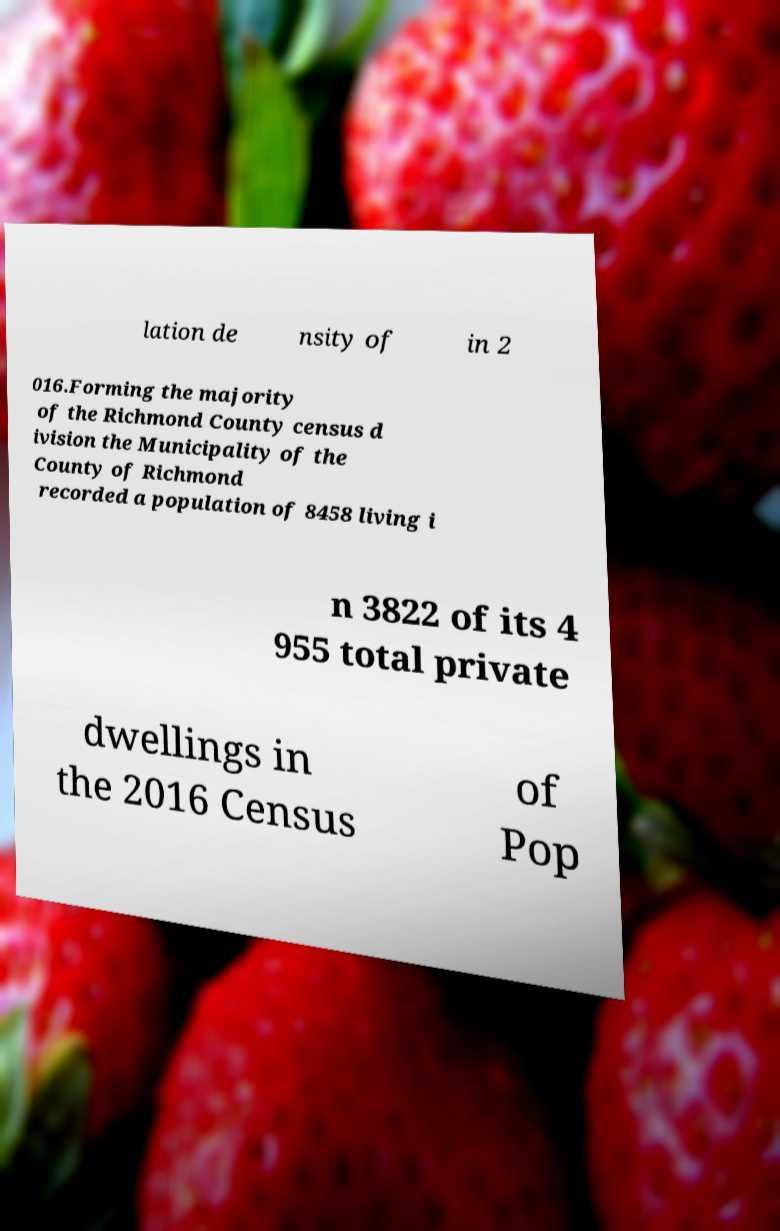Please read and relay the text visible in this image. What does it say? lation de nsity of in 2 016.Forming the majority of the Richmond County census d ivision the Municipality of the County of Richmond recorded a population of 8458 living i n 3822 of its 4 955 total private dwellings in the 2016 Census of Pop 